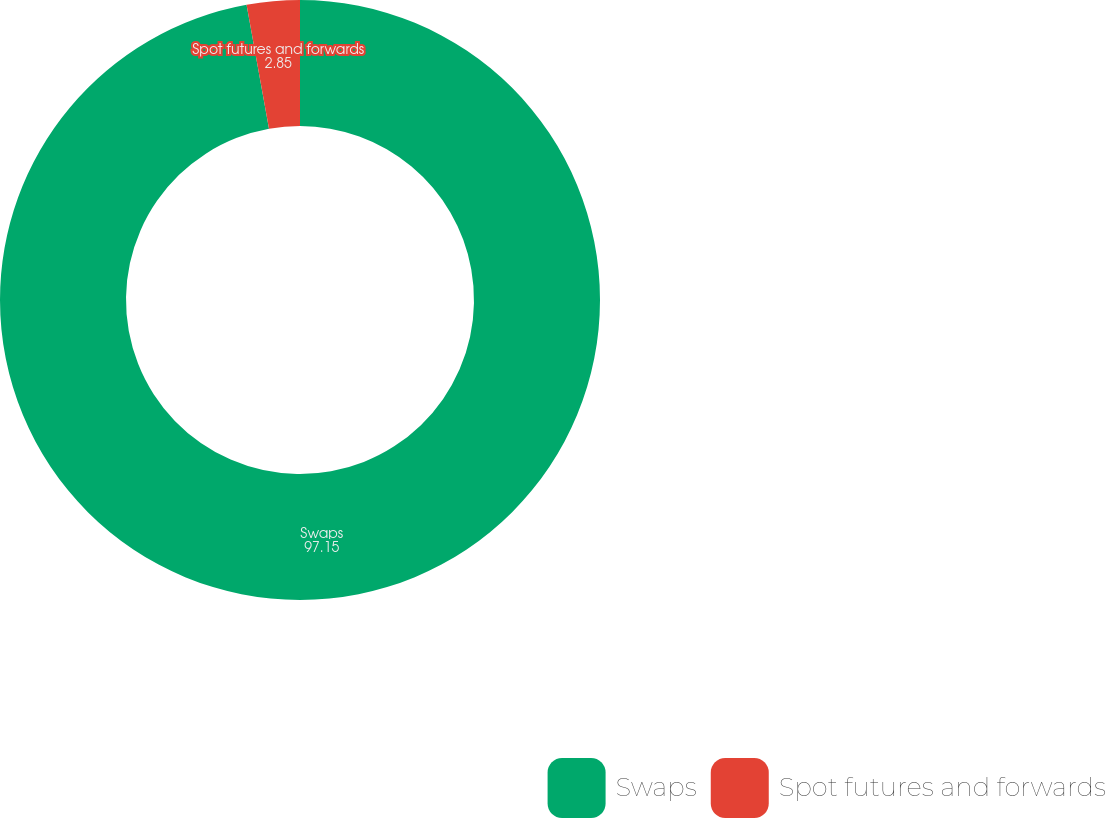Convert chart to OTSL. <chart><loc_0><loc_0><loc_500><loc_500><pie_chart><fcel>Swaps<fcel>Spot futures and forwards<nl><fcel>97.15%<fcel>2.85%<nl></chart> 